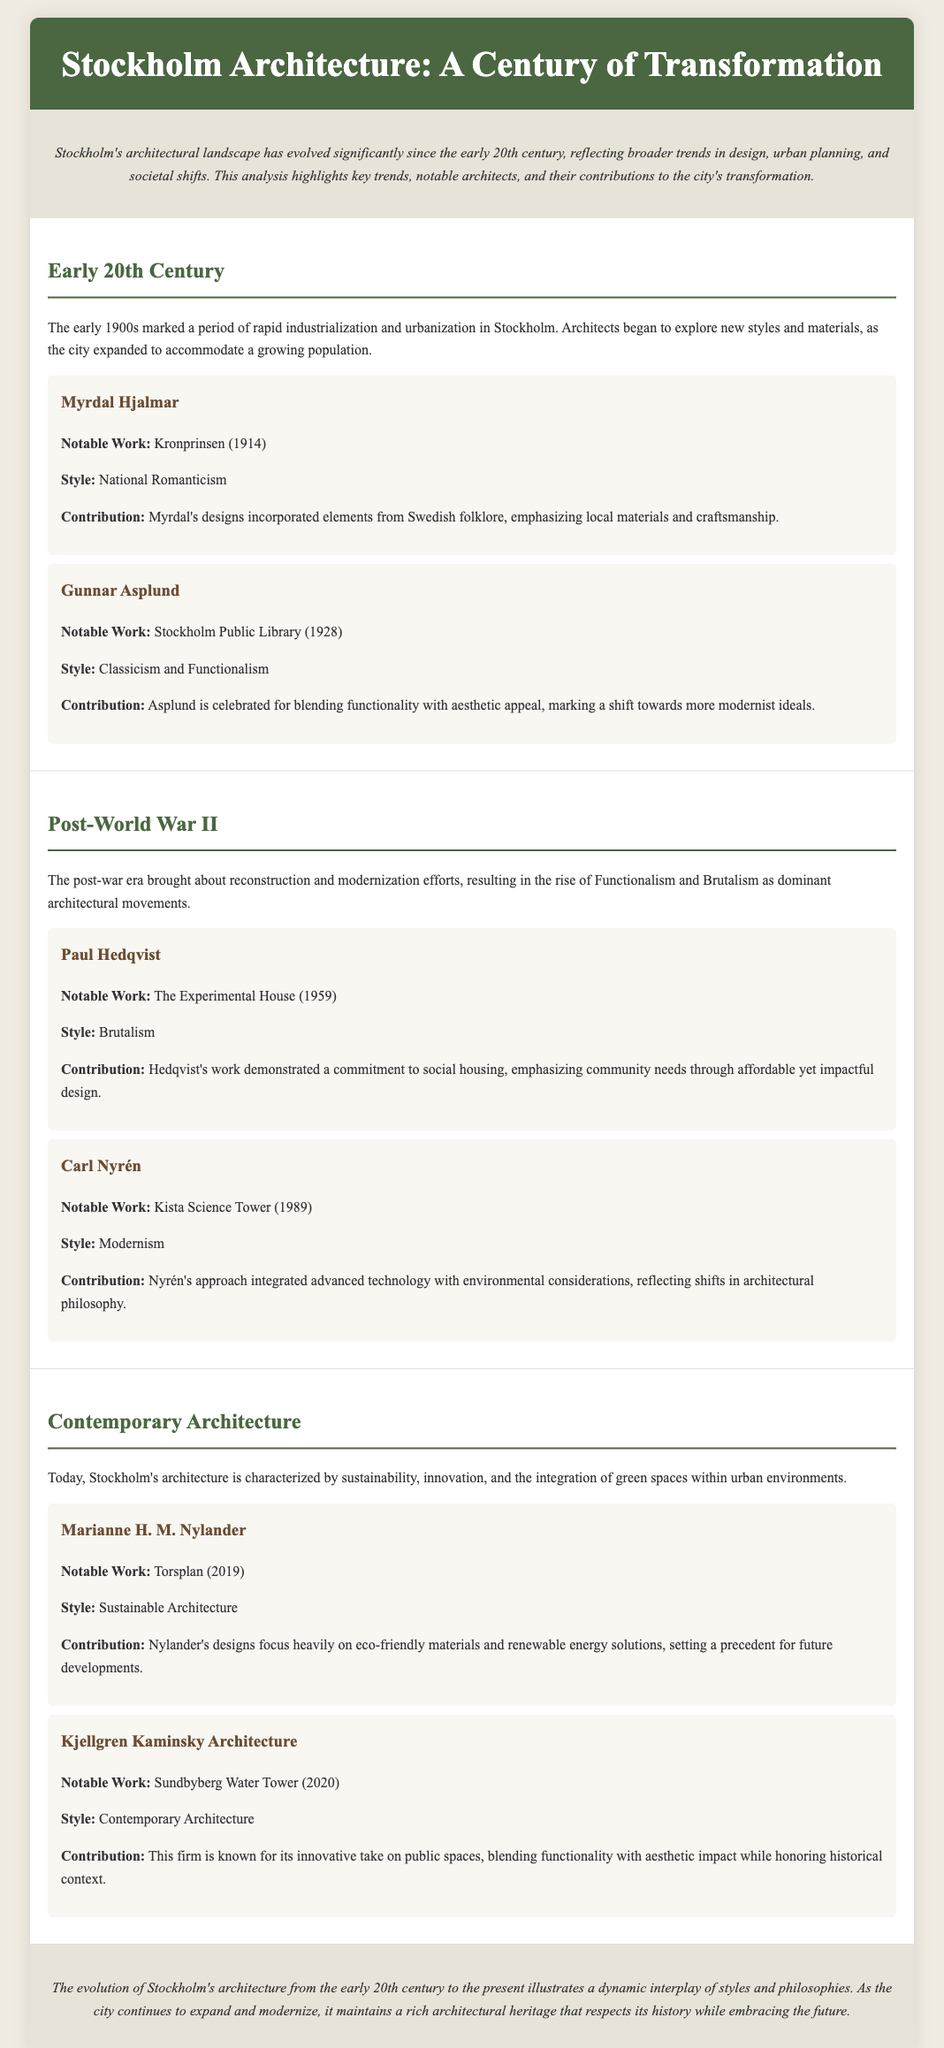What is the notable work of Myrdal Hjalmar? Myrdal Hjalmar's notable work mentioned in the document is Kronprinsen, completed in 1914.
Answer: Kronprinsen What style is associated with Gunnar Asplund? The document states that Gunnar Asplund's style is a blend of Classicism and Functionalism.
Answer: Classicism and Functionalism When was the Stockholm Public Library completed? According to the document, the Stockholm Public Library was completed in 1928.
Answer: 1928 Who is known for the Kista Science Tower? The document identifies Carl Nyrén as the architect known for the Kista Science Tower.
Answer: Carl Nyrén What architectural style did Paul Hedqvist adhere to? Paul Hedqvist is associated with the architectural style of Brutalism.
Answer: Brutalism What does Marianne H. M. Nylander's work focus on? Marianne H. M. Nylander's work focuses heavily on eco-friendly materials and renewable energy solutions.
Answer: Eco-friendly materials and renewable energy solutions Which architect designed the Sundbyberg Water Tower? The document indicates that Kjellgren Kaminsky Architecture designed the Sundbyberg Water Tower.
Answer: Kjellgren Kaminsky Architecture What is a key characteristic of contemporary architecture in Stockholm? The document states that contemporary architecture in Stockholm is characterized by sustainability.
Answer: Sustainability What was the primary focus during the post-war era? The primary focus during the post-war era was on reconstruction and modernization efforts.
Answer: Reconstruction and modernization efforts 